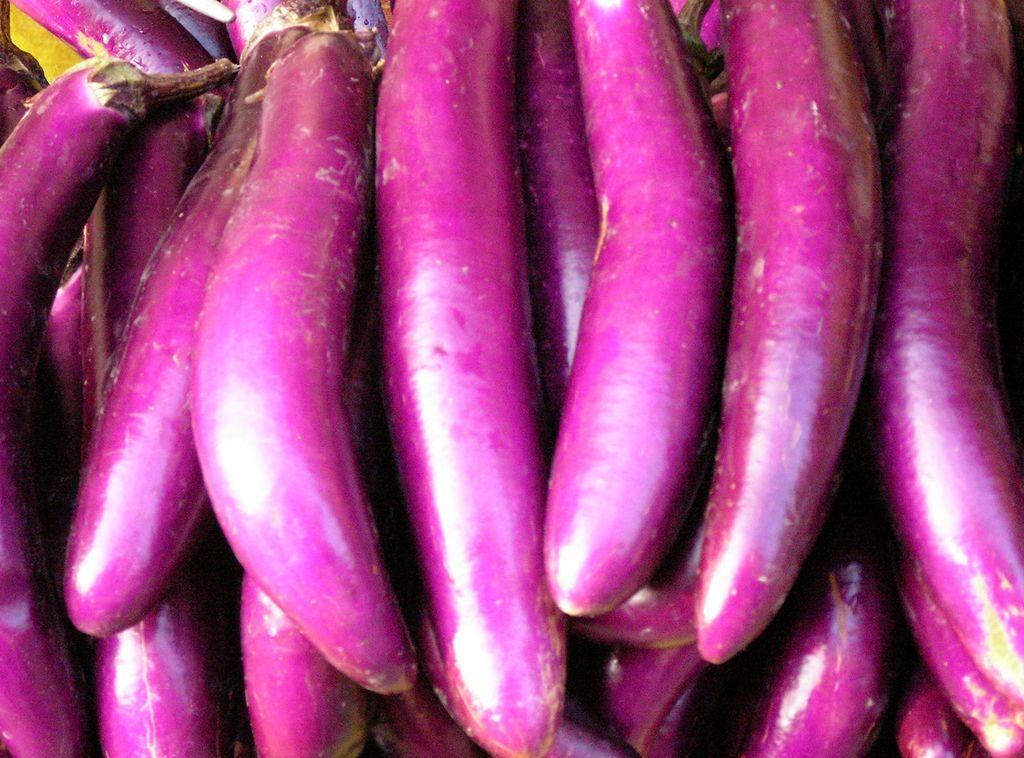Please provide a concise description of this image. In this image we can see brinjals. 